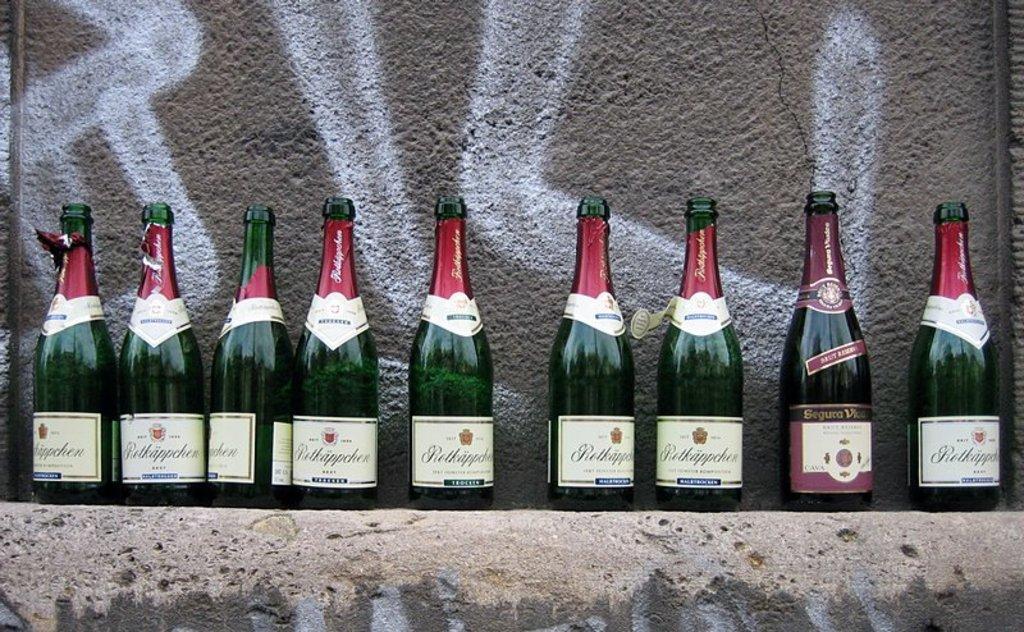Can you describe this image briefly? As we can see in the image, there are some green color bottles arranged in a sequence. Behind the bottles there's a wall. 